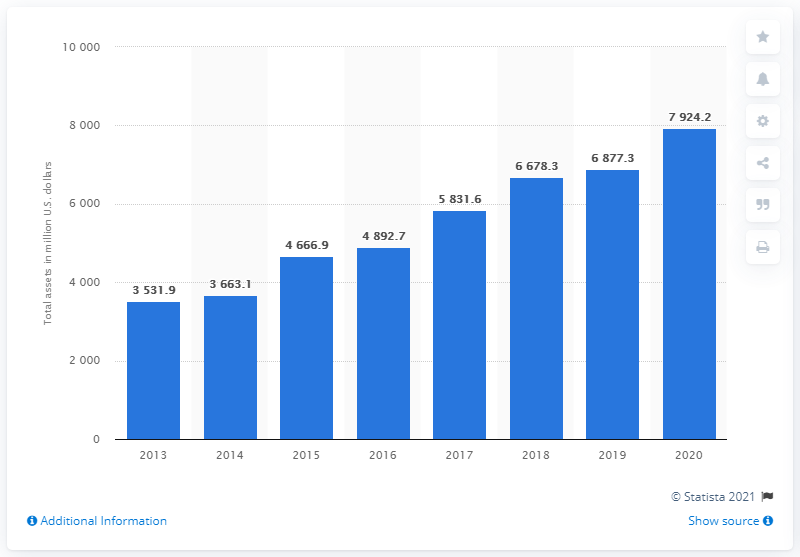Identify some key points in this picture. Tapestry Incorporated's total assets in 2020 were approximately 7,924.2 million dollars. 